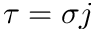<formula> <loc_0><loc_0><loc_500><loc_500>\tau = \sigma j</formula> 